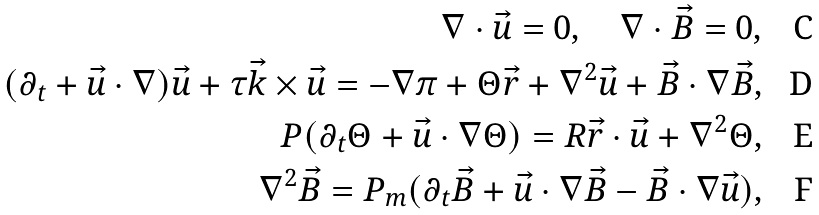<formula> <loc_0><loc_0><loc_500><loc_500>\nabla \cdot \vec { u } = 0 , \quad \nabla \cdot \vec { B } = 0 , \\ ( \partial _ { t } + \vec { u } \cdot \nabla ) \vec { u } + \tau \vec { k } \times \vec { u } = - \nabla \pi + \Theta \vec { r } + \nabla ^ { 2 } \vec { u } + \vec { B } \cdot \nabla \vec { B } , \\ P ( \partial _ { t } \Theta + \vec { u } \cdot \nabla \Theta ) = R \vec { r } \cdot \vec { u } + \nabla ^ { 2 } \Theta , \\ \nabla ^ { 2 } \vec { B } = P _ { m } ( \partial _ { t } \vec { B } + \vec { u } \cdot \nabla \vec { B } - \vec { B } \cdot \nabla \vec { u } ) ,</formula> 